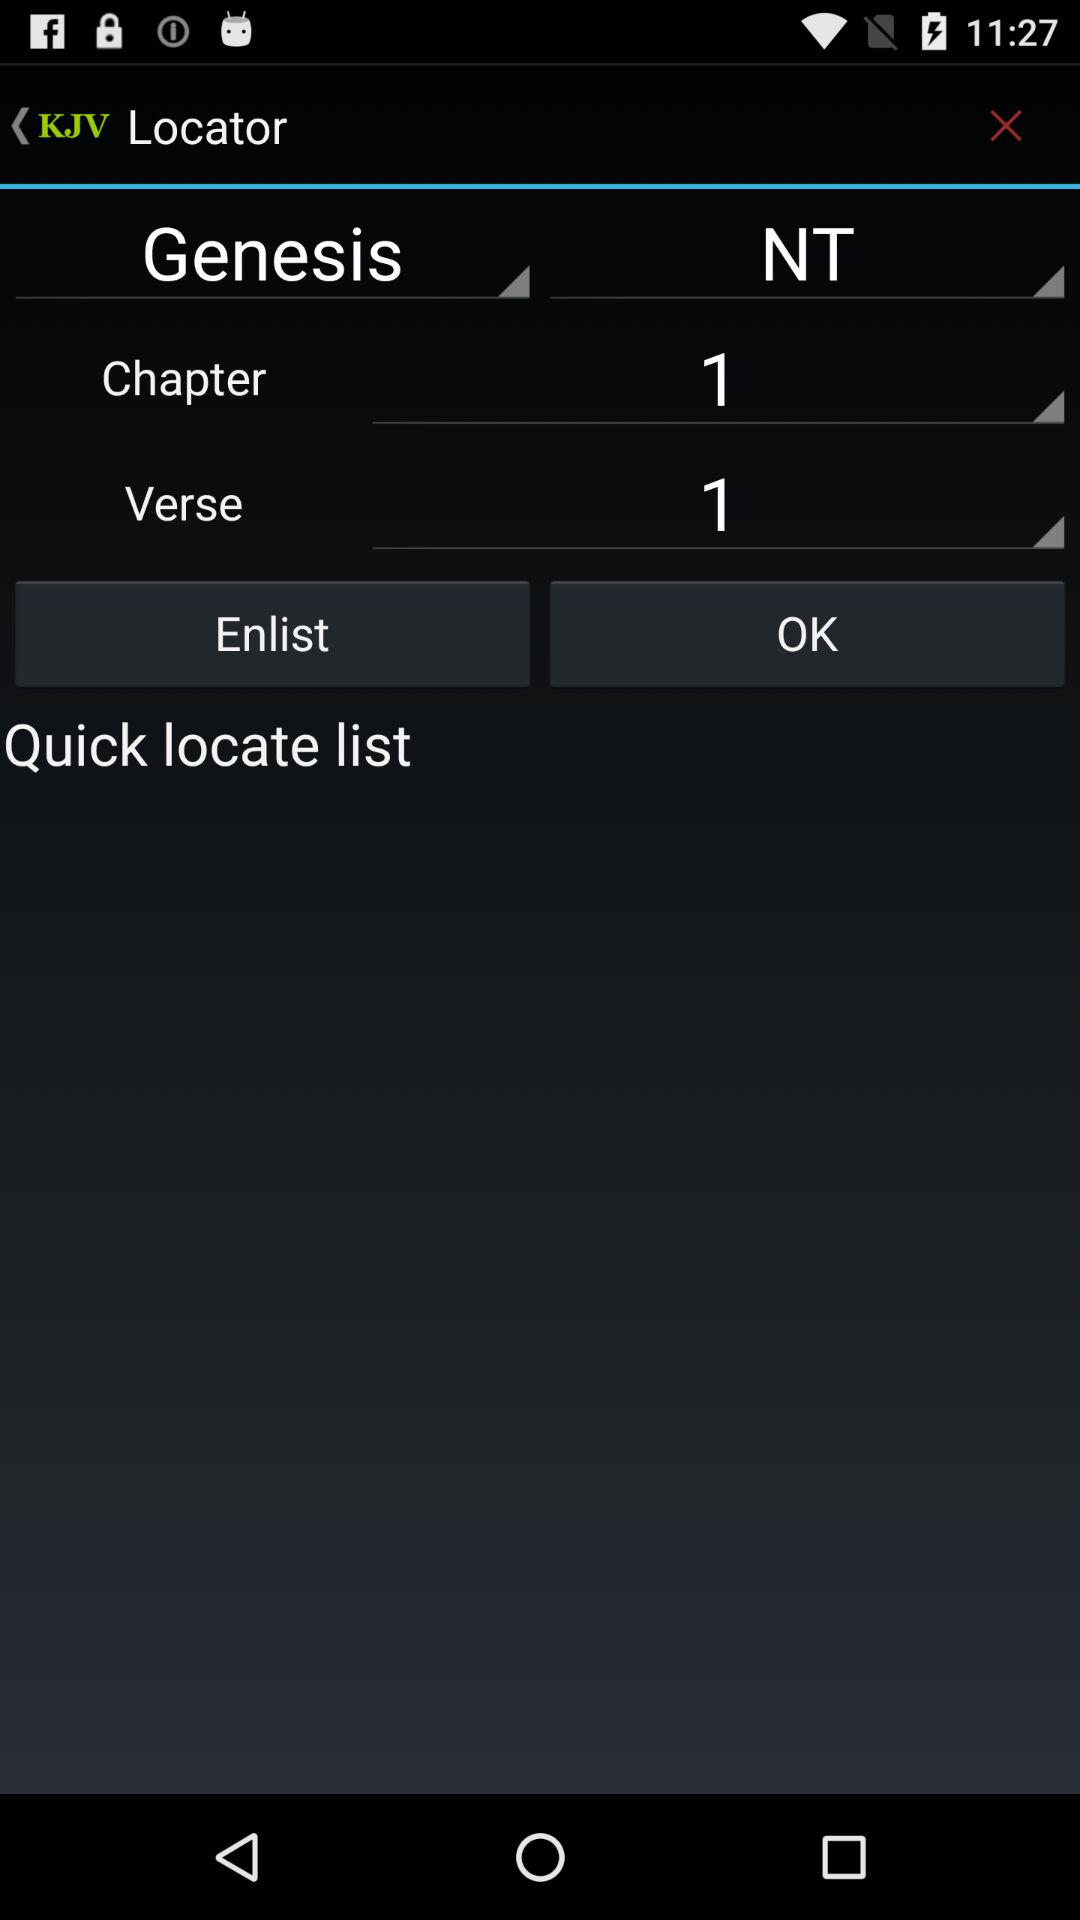What's the selected chapter number of "Genesis" in "Locator"? The selected chapter number of "Genesis" in "Locator" is 1. 